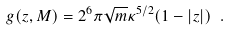<formula> <loc_0><loc_0><loc_500><loc_500>g ( z , M ) = 2 ^ { 6 } \pi \sqrt { m } \kappa ^ { 5 / 2 } ( 1 - | z | ) \ .</formula> 